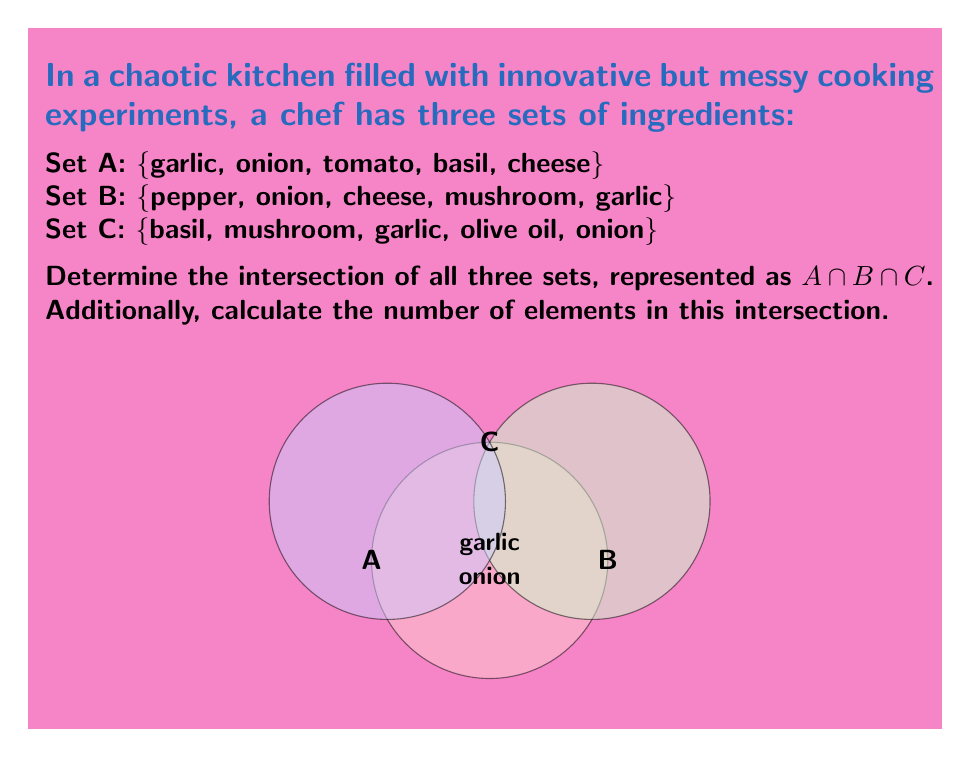What is the answer to this math problem? To find the intersection of sets A, B, and C, we need to identify the elements that are common to all three sets. Let's approach this step-by-step:

1) First, let's list out each set:
   Set A: {garlic, onion, tomato, basil, cheese}
   Set B: {pepper, onion, cheese, mushroom, garlic}
   Set C: {basil, mushroom, garlic, olive oil, onion}

2) Now, we need to find elements that appear in all three sets:

   - garlic: appears in A, B, and C
   - onion: appears in A, B, and C
   - tomato: only in A
   - basil: in A and C, but not B
   - cheese: in A and B, but not C
   - pepper: only in B
   - mushroom: in B and C, but not A
   - olive oil: only in C

3) Therefore, the elements that appear in all three sets are garlic and onion.

4) We can express this mathematically as:
   
   $A \cap B \cap C = \{garlic, onion\}$

5) To calculate the number of elements in this intersection, we simply count the elements in the resulting set. There are 2 elements in the intersection.
Answer: $A \cap B \cap C = \{garlic, onion\}$; $|A \cap B \cap C| = 2$ 